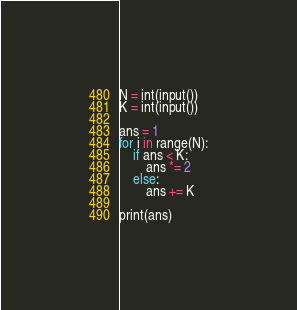Convert code to text. <code><loc_0><loc_0><loc_500><loc_500><_Python_>N = int(input())
K = int(input())

ans = 1
for i in range(N):
    if ans < K:
        ans *= 2
    else:
        ans += K

print(ans)
</code> 